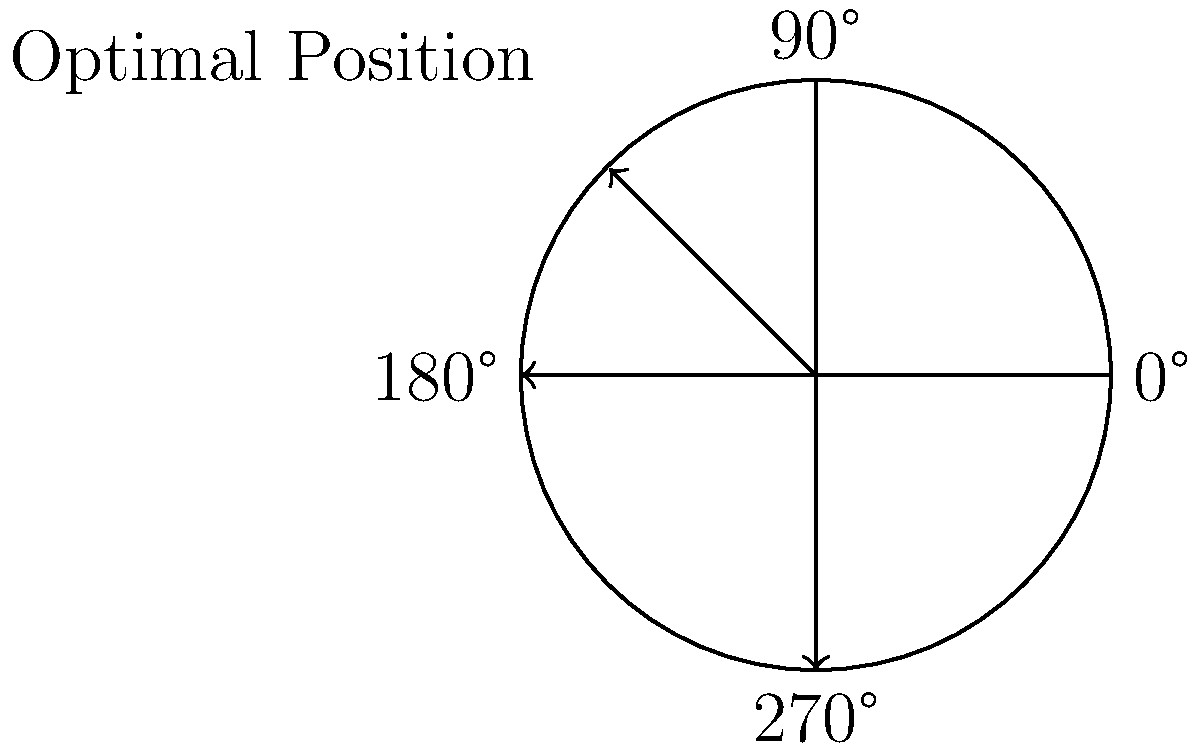As a talented athlete, you're experimenting with the optimal position for your new discus. The diagram shows a top view of the discus, with angles marked around its circumference. If the optimal throwing position is at 135°, how many degrees would you need to rotate the discus clockwise from its current position to reach the optimal throwing angle? To solve this problem, we need to follow these steps:

1. Identify the current position of the discus:
   The arrow in the diagram points to the top-left quadrant, which is between 90° and 180°.

2. Determine the exact current position:
   The arrow appears to be at the midpoint between 90° and 180°, which is 135°.

3. Identify the target position:
   The question states that the optimal throwing position is at 135°.

4. Calculate the rotation needed:
   Since the current position (135°) is already at the optimal throwing position (135°), no rotation is needed.

5. Convert to clockwise rotation:
   Even though no rotation is needed, we can express this as a full 360° rotation clockwise to return to the same position.

Therefore, you would need to rotate the discus 360° clockwise (or 0°, which is equivalent) to reach the optimal throwing angle.
Answer: 360° 